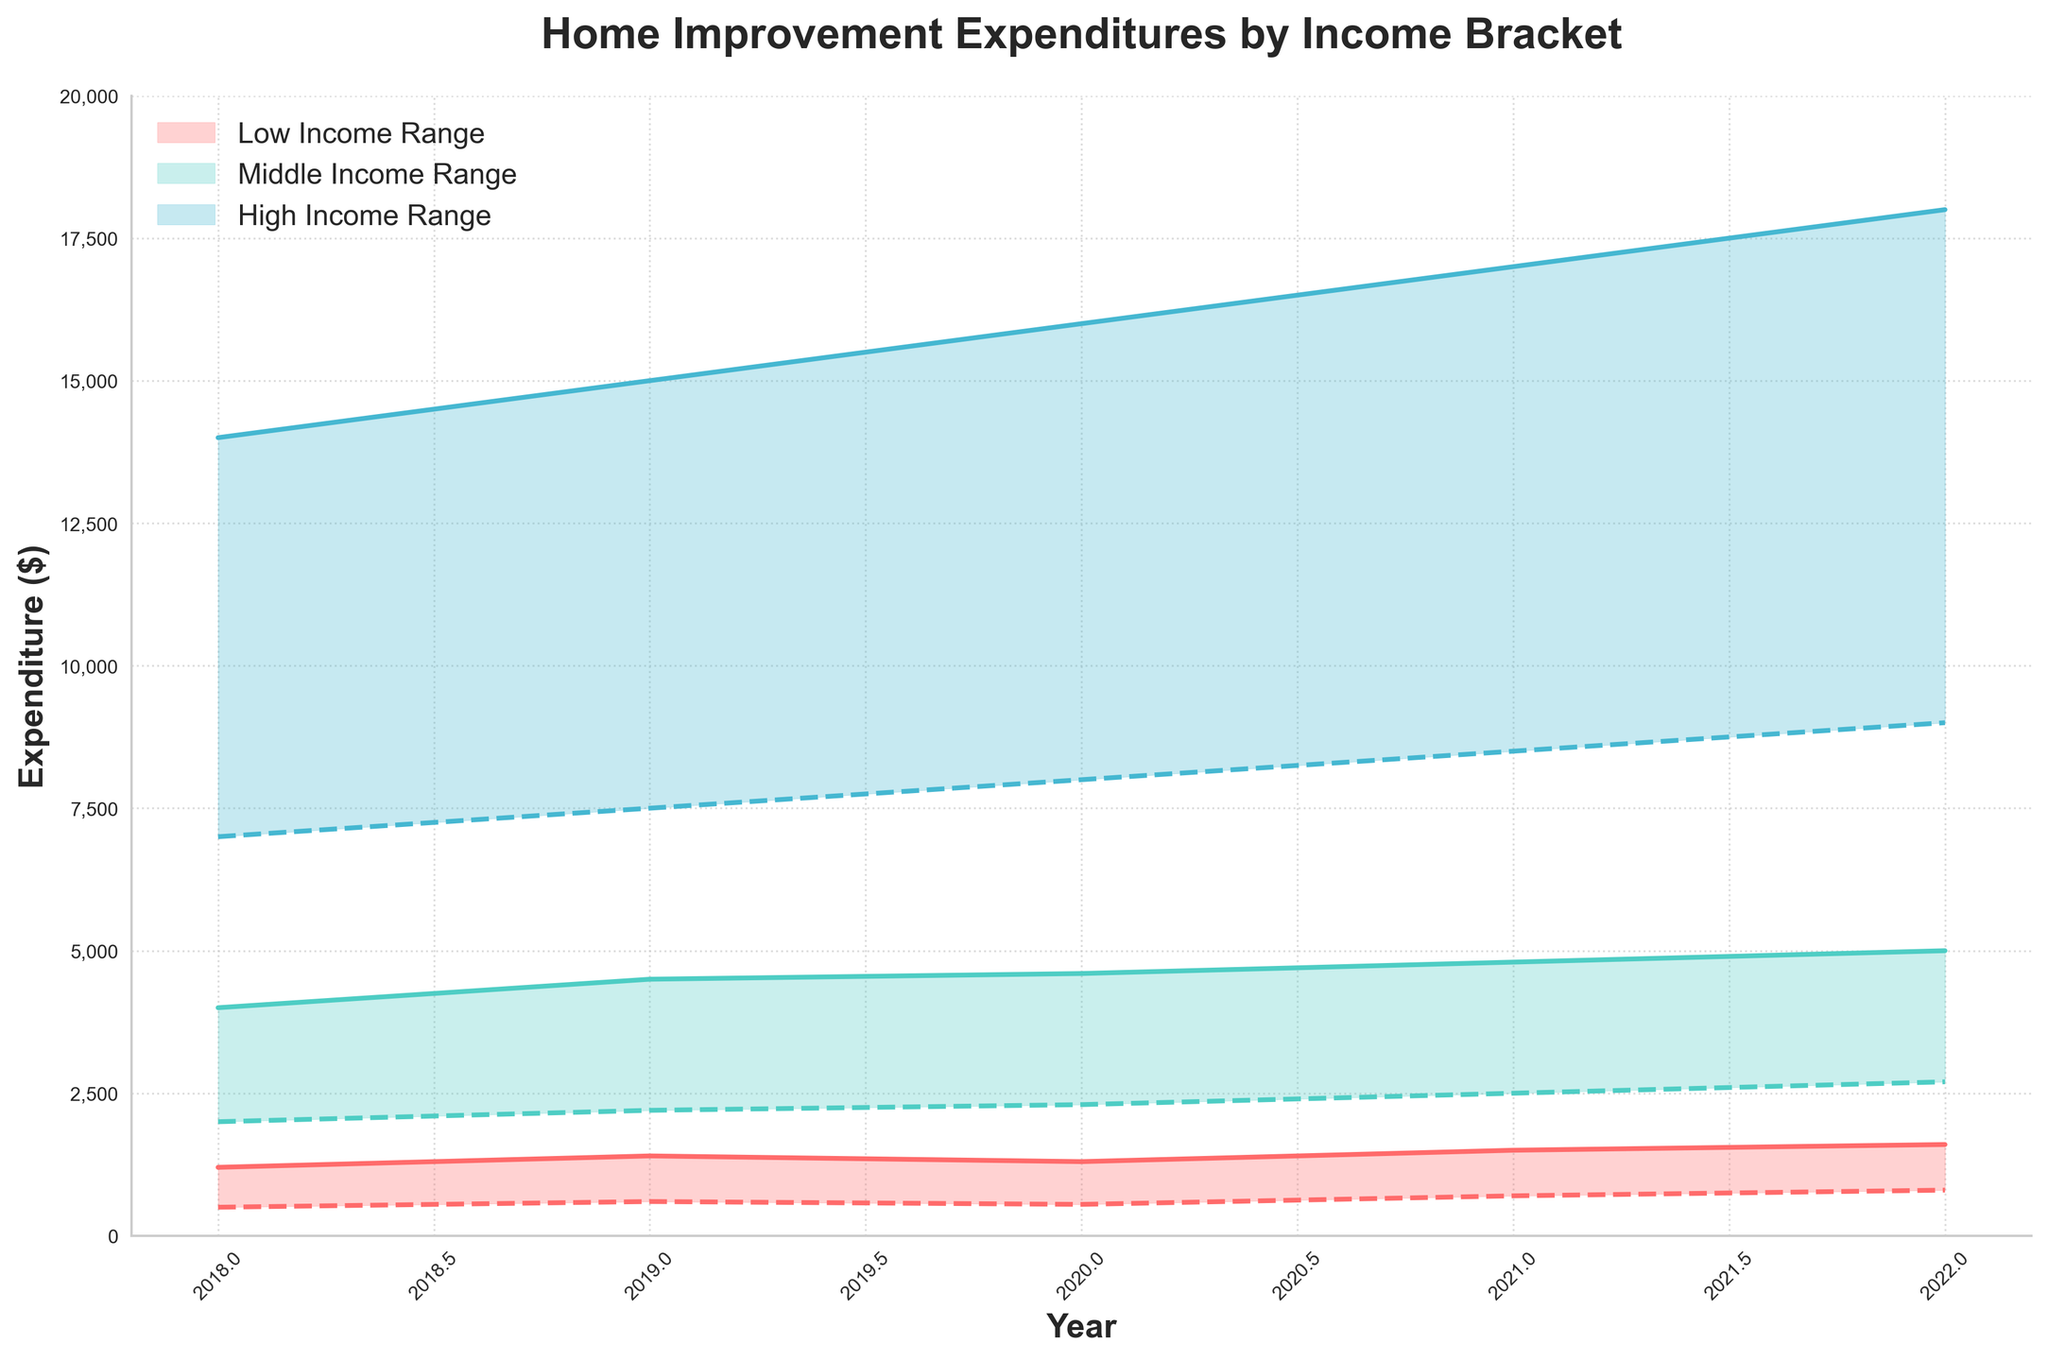What is the title of the chart? The title is displayed at the top of the chart and gives a summary of what the chart is about.
Answer: Home Improvement Expenditures by Income Bracket What are the years displayed on the x-axis? The x-axis shows the range of years for which the data is plotted. By looking at the labels along the x-axis, we can identify the years.
Answer: 2018, 2019, 2020, 2021, 2022 Which income bracket has the highest maximum expenditure in 2022? To answer this, look at the maximum expenditure plots for each income bracket in 2022 and identify the one with the highest value.
Answer: High Income What is the minimum expenditure for Low Income in 2019? This is visible by looking at the minimum part of the range area for the Low Income bracket in 2019.
Answer: 600 By how much did the minimum expenditure for Middle Income increase from 2018 to 2022? Subtract the minimum expenditure value for Middle Income in 2018 from the value in 2022.
Answer: 700 What is the expenditure range for High Income in 2020? To identify this, look at the minimum and maximum expenditure values for High Income in 2020.
Answer: 8,000 to 16,000 Which income bracket shows the widest range in expenditures in 2021? Compare the difference between the maximum and minimum expenditures for each income bracket in 2021.
Answer: High Income Compare the trends in maximum expenditures from 2018 to 2022 between Low Income and Middle Income brackets. Observe the slopes of the maximum expenditure lines for both Low Income and Middle Income from 2018 to 2022 and compare the steepness and direction of these trends.
Answer: Both increased, but Middle Income had a steeper increase What is the overall trend in minimum expenditures for Low Income from 2018 to 2022? To identify this, observe the pattern of the minimum expenditure line for Low Income across the years.
Answer: Increasing Which year displays the smallest expenditure range for Middle Income? Identify the year by finding the smallest difference between minimum and maximum expenditures for Middle Income.
Answer: 2018 